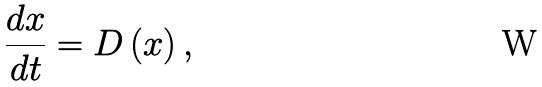Convert formula to latex. <formula><loc_0><loc_0><loc_500><loc_500>\frac { d x } { d t } = D \left ( { x } \right ) ,</formula> 